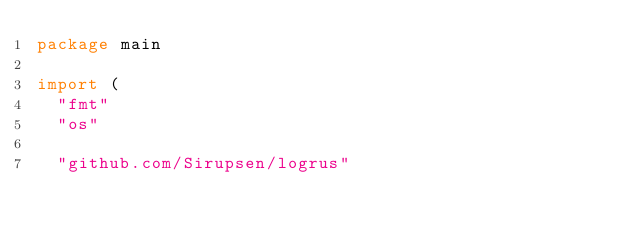<code> <loc_0><loc_0><loc_500><loc_500><_Go_>package main

import (
	"fmt"
	"os"

	"github.com/Sirupsen/logrus"</code> 